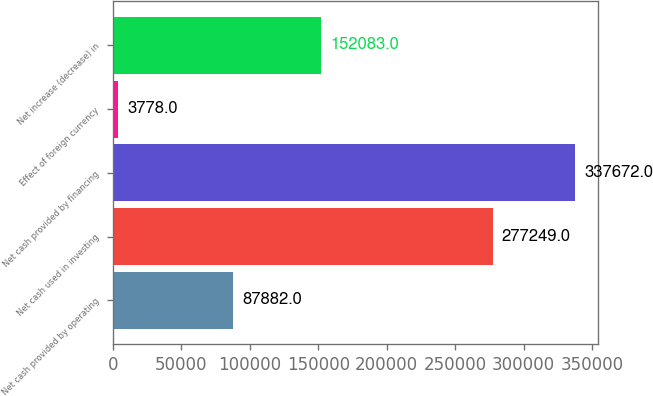Convert chart to OTSL. <chart><loc_0><loc_0><loc_500><loc_500><bar_chart><fcel>Net cash provided by operating<fcel>Net cash used in investing<fcel>Net cash provided by financing<fcel>Effect of foreign currency<fcel>Net increase (decrease) in<nl><fcel>87882<fcel>277249<fcel>337672<fcel>3778<fcel>152083<nl></chart> 